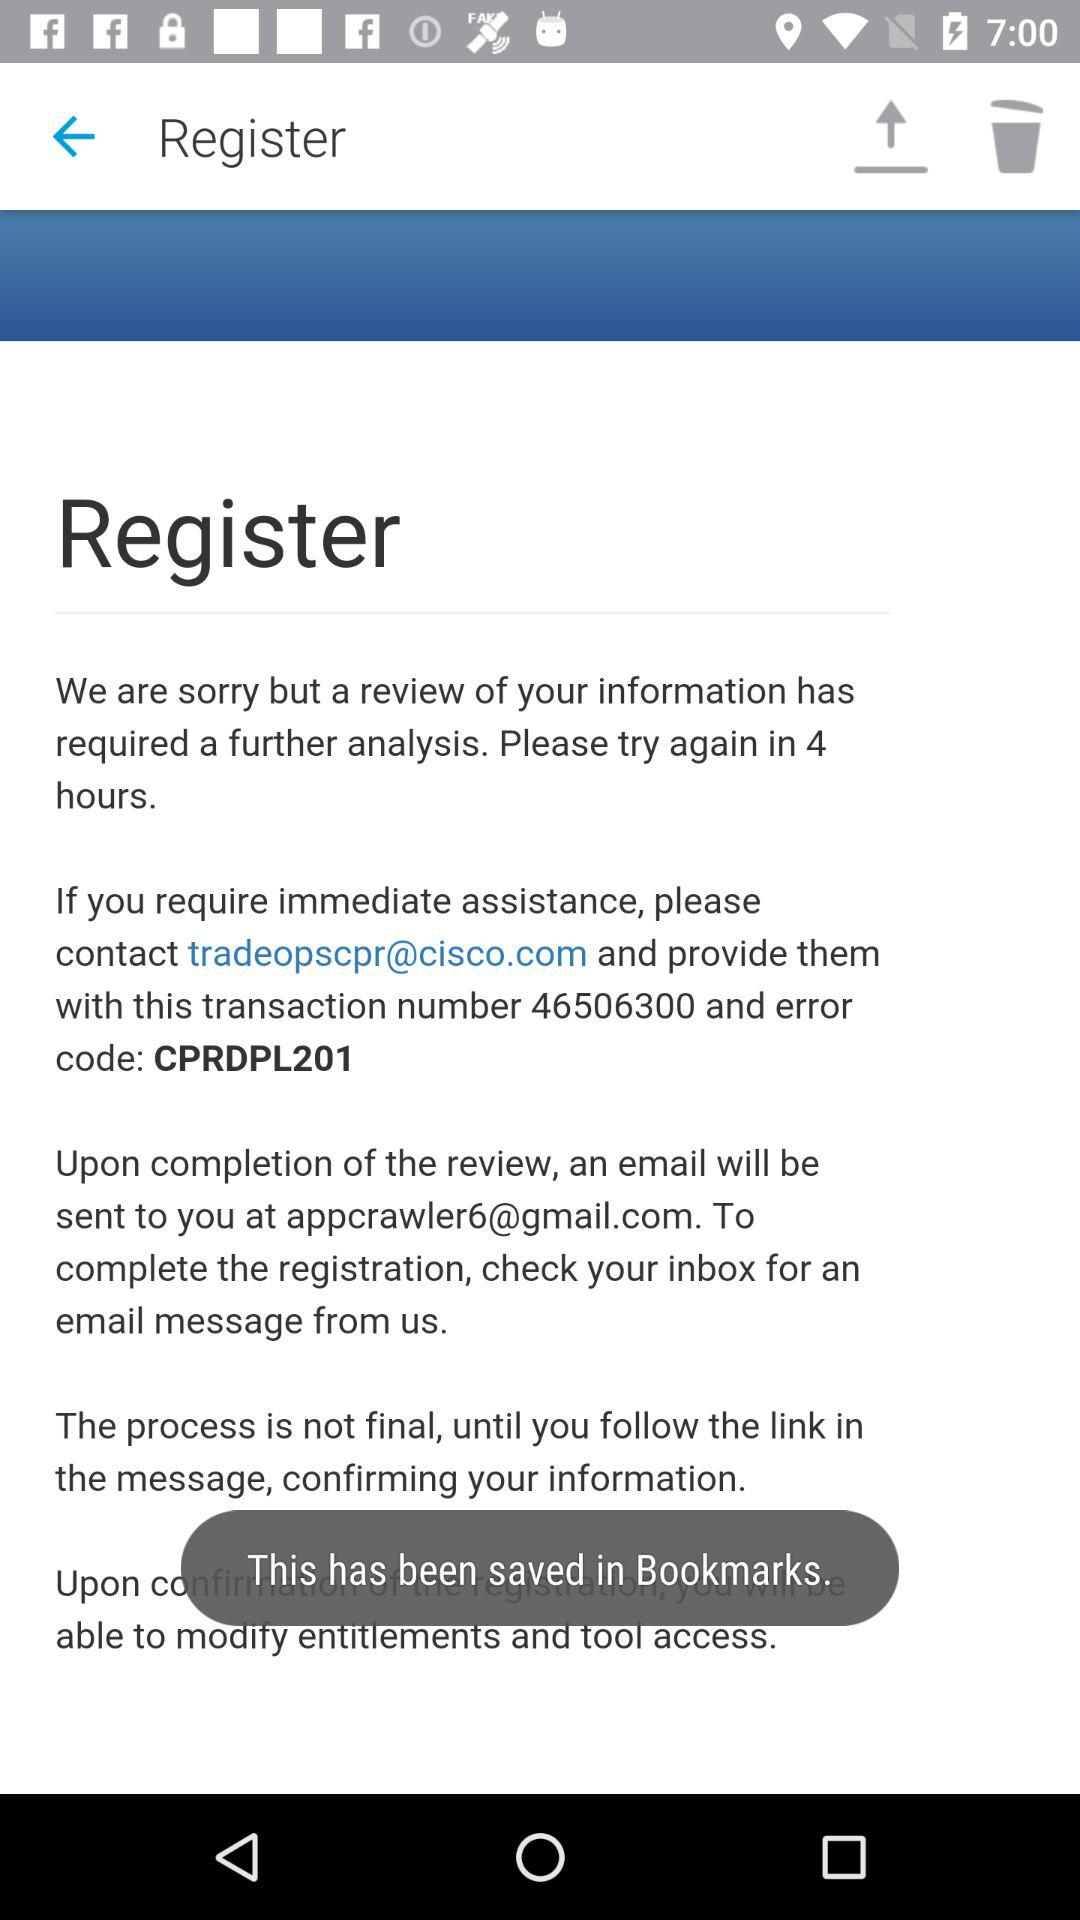In what setting has the data been saved? This has been saved in Bookmarks. 